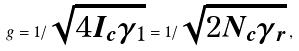<formula> <loc_0><loc_0><loc_500><loc_500>g = 1 / \sqrt { 4 I _ { c } \gamma _ { 1 } } = 1 / \sqrt { 2 N _ { c } \gamma _ { r } } \, ,</formula> 